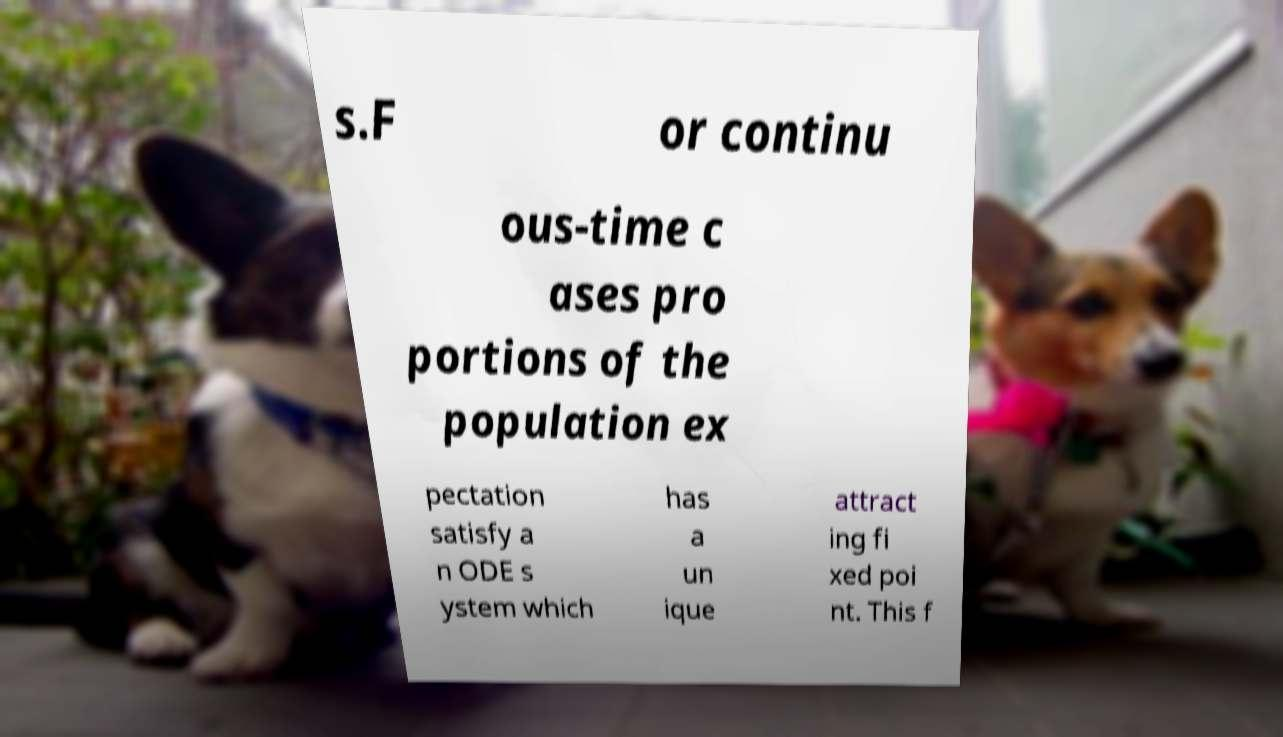Could you assist in decoding the text presented in this image and type it out clearly? s.F or continu ous-time c ases pro portions of the population ex pectation satisfy a n ODE s ystem which has a un ique attract ing fi xed poi nt. This f 